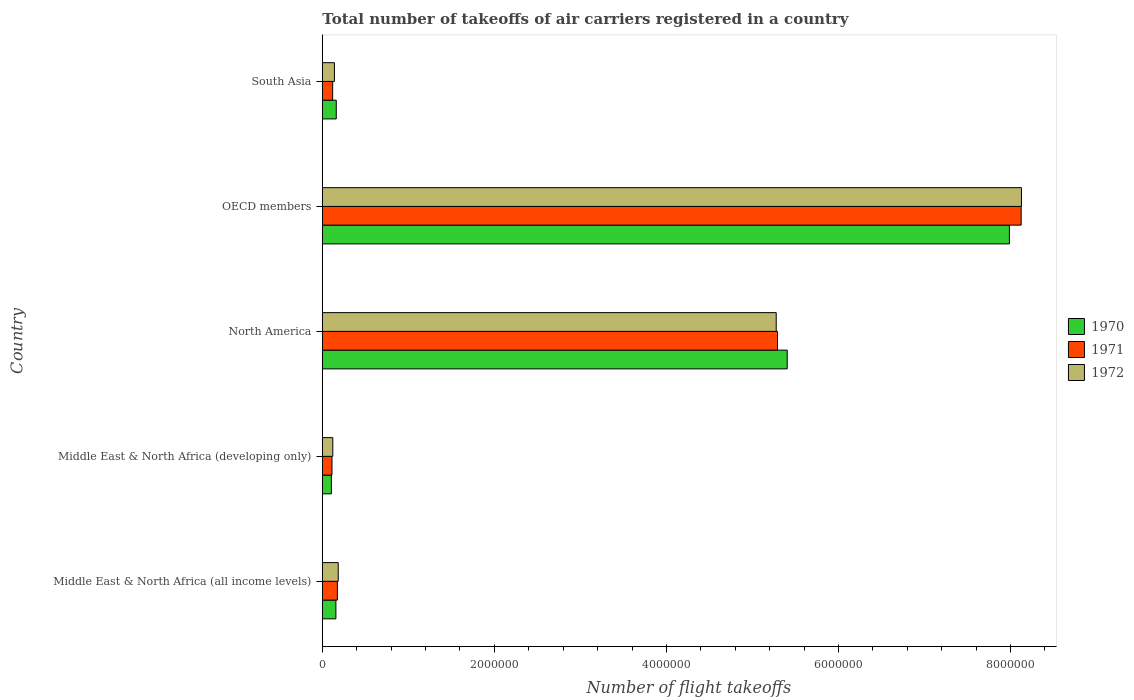How many different coloured bars are there?
Provide a short and direct response. 3. Are the number of bars per tick equal to the number of legend labels?
Your response must be concise. Yes. Are the number of bars on each tick of the Y-axis equal?
Ensure brevity in your answer.  Yes. How many bars are there on the 4th tick from the bottom?
Provide a short and direct response. 3. What is the label of the 1st group of bars from the top?
Provide a succinct answer. South Asia. In how many cases, is the number of bars for a given country not equal to the number of legend labels?
Make the answer very short. 0. What is the total number of flight takeoffs in 1972 in North America?
Provide a short and direct response. 5.28e+06. Across all countries, what is the maximum total number of flight takeoffs in 1972?
Provide a succinct answer. 8.13e+06. Across all countries, what is the minimum total number of flight takeoffs in 1971?
Offer a terse response. 1.12e+05. In which country was the total number of flight takeoffs in 1972 minimum?
Make the answer very short. Middle East & North Africa (developing only). What is the total total number of flight takeoffs in 1971 in the graph?
Offer a terse response. 1.38e+07. What is the difference between the total number of flight takeoffs in 1970 in Middle East & North Africa (all income levels) and that in South Asia?
Your response must be concise. -4300. What is the difference between the total number of flight takeoffs in 1971 in North America and the total number of flight takeoffs in 1970 in Middle East & North Africa (developing only)?
Your answer should be very brief. 5.19e+06. What is the average total number of flight takeoffs in 1972 per country?
Give a very brief answer. 2.77e+06. What is the ratio of the total number of flight takeoffs in 1972 in North America to that in OECD members?
Make the answer very short. 0.65. What is the difference between the highest and the second highest total number of flight takeoffs in 1970?
Offer a very short reply. 2.58e+06. What is the difference between the highest and the lowest total number of flight takeoffs in 1971?
Provide a short and direct response. 8.01e+06. Is the sum of the total number of flight takeoffs in 1971 in Middle East & North Africa (developing only) and North America greater than the maximum total number of flight takeoffs in 1970 across all countries?
Your answer should be very brief. No. What does the 3rd bar from the bottom in Middle East & North Africa (all income levels) represents?
Offer a very short reply. 1972. What is the difference between two consecutive major ticks on the X-axis?
Provide a short and direct response. 2.00e+06. Are the values on the major ticks of X-axis written in scientific E-notation?
Give a very brief answer. No. Does the graph contain any zero values?
Offer a very short reply. No. Does the graph contain grids?
Provide a short and direct response. No. What is the title of the graph?
Your response must be concise. Total number of takeoffs of air carriers registered in a country. Does "1995" appear as one of the legend labels in the graph?
Ensure brevity in your answer.  No. What is the label or title of the X-axis?
Your response must be concise. Number of flight takeoffs. What is the label or title of the Y-axis?
Your answer should be compact. Country. What is the Number of flight takeoffs in 1970 in Middle East & North Africa (all income levels)?
Keep it short and to the point. 1.58e+05. What is the Number of flight takeoffs in 1971 in Middle East & North Africa (all income levels)?
Your answer should be very brief. 1.75e+05. What is the Number of flight takeoffs in 1972 in Middle East & North Africa (all income levels)?
Give a very brief answer. 1.85e+05. What is the Number of flight takeoffs in 1970 in Middle East & North Africa (developing only)?
Keep it short and to the point. 1.05e+05. What is the Number of flight takeoffs of 1971 in Middle East & North Africa (developing only)?
Give a very brief answer. 1.12e+05. What is the Number of flight takeoffs in 1972 in Middle East & North Africa (developing only)?
Your response must be concise. 1.22e+05. What is the Number of flight takeoffs in 1970 in North America?
Provide a short and direct response. 5.40e+06. What is the Number of flight takeoffs of 1971 in North America?
Provide a short and direct response. 5.29e+06. What is the Number of flight takeoffs in 1972 in North America?
Keep it short and to the point. 5.28e+06. What is the Number of flight takeoffs in 1970 in OECD members?
Provide a short and direct response. 7.99e+06. What is the Number of flight takeoffs in 1971 in OECD members?
Provide a succinct answer. 8.12e+06. What is the Number of flight takeoffs in 1972 in OECD members?
Your response must be concise. 8.13e+06. What is the Number of flight takeoffs in 1970 in South Asia?
Ensure brevity in your answer.  1.62e+05. What is the Number of flight takeoffs of 1971 in South Asia?
Provide a short and direct response. 1.20e+05. What is the Number of flight takeoffs in 1972 in South Asia?
Ensure brevity in your answer.  1.41e+05. Across all countries, what is the maximum Number of flight takeoffs in 1970?
Your answer should be compact. 7.99e+06. Across all countries, what is the maximum Number of flight takeoffs of 1971?
Your response must be concise. 8.12e+06. Across all countries, what is the maximum Number of flight takeoffs of 1972?
Offer a very short reply. 8.13e+06. Across all countries, what is the minimum Number of flight takeoffs of 1970?
Provide a succinct answer. 1.05e+05. Across all countries, what is the minimum Number of flight takeoffs of 1971?
Offer a terse response. 1.12e+05. Across all countries, what is the minimum Number of flight takeoffs of 1972?
Offer a terse response. 1.22e+05. What is the total Number of flight takeoffs of 1970 in the graph?
Keep it short and to the point. 1.38e+07. What is the total Number of flight takeoffs in 1971 in the graph?
Offer a very short reply. 1.38e+07. What is the total Number of flight takeoffs of 1972 in the graph?
Keep it short and to the point. 1.39e+07. What is the difference between the Number of flight takeoffs of 1970 in Middle East & North Africa (all income levels) and that in Middle East & North Africa (developing only)?
Give a very brief answer. 5.23e+04. What is the difference between the Number of flight takeoffs of 1971 in Middle East & North Africa (all income levels) and that in Middle East & North Africa (developing only)?
Ensure brevity in your answer.  6.26e+04. What is the difference between the Number of flight takeoffs in 1972 in Middle East & North Africa (all income levels) and that in Middle East & North Africa (developing only)?
Provide a short and direct response. 6.32e+04. What is the difference between the Number of flight takeoffs in 1970 in Middle East & North Africa (all income levels) and that in North America?
Keep it short and to the point. -5.25e+06. What is the difference between the Number of flight takeoffs in 1971 in Middle East & North Africa (all income levels) and that in North America?
Your answer should be very brief. -5.12e+06. What is the difference between the Number of flight takeoffs in 1972 in Middle East & North Africa (all income levels) and that in North America?
Your answer should be compact. -5.09e+06. What is the difference between the Number of flight takeoffs in 1970 in Middle East & North Africa (all income levels) and that in OECD members?
Your response must be concise. -7.83e+06. What is the difference between the Number of flight takeoffs in 1971 in Middle East & North Africa (all income levels) and that in OECD members?
Your answer should be very brief. -7.95e+06. What is the difference between the Number of flight takeoffs in 1972 in Middle East & North Africa (all income levels) and that in OECD members?
Give a very brief answer. -7.94e+06. What is the difference between the Number of flight takeoffs of 1970 in Middle East & North Africa (all income levels) and that in South Asia?
Provide a short and direct response. -4300. What is the difference between the Number of flight takeoffs of 1971 in Middle East & North Africa (all income levels) and that in South Asia?
Make the answer very short. 5.48e+04. What is the difference between the Number of flight takeoffs in 1972 in Middle East & North Africa (all income levels) and that in South Asia?
Your answer should be very brief. 4.41e+04. What is the difference between the Number of flight takeoffs of 1970 in Middle East & North Africa (developing only) and that in North America?
Your answer should be compact. -5.30e+06. What is the difference between the Number of flight takeoffs in 1971 in Middle East & North Africa (developing only) and that in North America?
Your answer should be very brief. -5.18e+06. What is the difference between the Number of flight takeoffs of 1972 in Middle East & North Africa (developing only) and that in North America?
Your answer should be very brief. -5.15e+06. What is the difference between the Number of flight takeoffs in 1970 in Middle East & North Africa (developing only) and that in OECD members?
Your response must be concise. -7.88e+06. What is the difference between the Number of flight takeoffs of 1971 in Middle East & North Africa (developing only) and that in OECD members?
Offer a terse response. -8.01e+06. What is the difference between the Number of flight takeoffs in 1972 in Middle East & North Africa (developing only) and that in OECD members?
Provide a short and direct response. -8.01e+06. What is the difference between the Number of flight takeoffs of 1970 in Middle East & North Africa (developing only) and that in South Asia?
Provide a short and direct response. -5.66e+04. What is the difference between the Number of flight takeoffs in 1971 in Middle East & North Africa (developing only) and that in South Asia?
Offer a terse response. -7800. What is the difference between the Number of flight takeoffs in 1972 in Middle East & North Africa (developing only) and that in South Asia?
Offer a terse response. -1.91e+04. What is the difference between the Number of flight takeoffs in 1970 in North America and that in OECD members?
Give a very brief answer. -2.58e+06. What is the difference between the Number of flight takeoffs of 1971 in North America and that in OECD members?
Provide a short and direct response. -2.83e+06. What is the difference between the Number of flight takeoffs of 1972 in North America and that in OECD members?
Ensure brevity in your answer.  -2.85e+06. What is the difference between the Number of flight takeoffs of 1970 in North America and that in South Asia?
Offer a very short reply. 5.24e+06. What is the difference between the Number of flight takeoffs in 1971 in North America and that in South Asia?
Your answer should be compact. 5.17e+06. What is the difference between the Number of flight takeoffs in 1972 in North America and that in South Asia?
Your answer should be very brief. 5.14e+06. What is the difference between the Number of flight takeoffs in 1970 in OECD members and that in South Asia?
Offer a terse response. 7.83e+06. What is the difference between the Number of flight takeoffs of 1971 in OECD members and that in South Asia?
Give a very brief answer. 8.00e+06. What is the difference between the Number of flight takeoffs in 1972 in OECD members and that in South Asia?
Give a very brief answer. 7.99e+06. What is the difference between the Number of flight takeoffs in 1970 in Middle East & North Africa (all income levels) and the Number of flight takeoffs in 1971 in Middle East & North Africa (developing only)?
Keep it short and to the point. 4.54e+04. What is the difference between the Number of flight takeoffs in 1970 in Middle East & North Africa (all income levels) and the Number of flight takeoffs in 1972 in Middle East & North Africa (developing only)?
Ensure brevity in your answer.  3.60e+04. What is the difference between the Number of flight takeoffs in 1971 in Middle East & North Africa (all income levels) and the Number of flight takeoffs in 1972 in Middle East & North Africa (developing only)?
Give a very brief answer. 5.32e+04. What is the difference between the Number of flight takeoffs in 1970 in Middle East & North Africa (all income levels) and the Number of flight takeoffs in 1971 in North America?
Your answer should be compact. -5.13e+06. What is the difference between the Number of flight takeoffs in 1970 in Middle East & North Africa (all income levels) and the Number of flight takeoffs in 1972 in North America?
Make the answer very short. -5.12e+06. What is the difference between the Number of flight takeoffs of 1971 in Middle East & North Africa (all income levels) and the Number of flight takeoffs of 1972 in North America?
Your answer should be compact. -5.10e+06. What is the difference between the Number of flight takeoffs in 1970 in Middle East & North Africa (all income levels) and the Number of flight takeoffs in 1971 in OECD members?
Keep it short and to the point. -7.97e+06. What is the difference between the Number of flight takeoffs in 1970 in Middle East & North Africa (all income levels) and the Number of flight takeoffs in 1972 in OECD members?
Keep it short and to the point. -7.97e+06. What is the difference between the Number of flight takeoffs of 1971 in Middle East & North Africa (all income levels) and the Number of flight takeoffs of 1972 in OECD members?
Ensure brevity in your answer.  -7.95e+06. What is the difference between the Number of flight takeoffs in 1970 in Middle East & North Africa (all income levels) and the Number of flight takeoffs in 1971 in South Asia?
Keep it short and to the point. 3.76e+04. What is the difference between the Number of flight takeoffs in 1970 in Middle East & North Africa (all income levels) and the Number of flight takeoffs in 1972 in South Asia?
Provide a succinct answer. 1.69e+04. What is the difference between the Number of flight takeoffs of 1971 in Middle East & North Africa (all income levels) and the Number of flight takeoffs of 1972 in South Asia?
Ensure brevity in your answer.  3.41e+04. What is the difference between the Number of flight takeoffs in 1970 in Middle East & North Africa (developing only) and the Number of flight takeoffs in 1971 in North America?
Offer a very short reply. -5.19e+06. What is the difference between the Number of flight takeoffs of 1970 in Middle East & North Africa (developing only) and the Number of flight takeoffs of 1972 in North America?
Your response must be concise. -5.17e+06. What is the difference between the Number of flight takeoffs of 1971 in Middle East & North Africa (developing only) and the Number of flight takeoffs of 1972 in North America?
Offer a terse response. -5.16e+06. What is the difference between the Number of flight takeoffs of 1970 in Middle East & North Africa (developing only) and the Number of flight takeoffs of 1971 in OECD members?
Make the answer very short. -8.02e+06. What is the difference between the Number of flight takeoffs of 1970 in Middle East & North Africa (developing only) and the Number of flight takeoffs of 1972 in OECD members?
Your answer should be very brief. -8.02e+06. What is the difference between the Number of flight takeoffs in 1971 in Middle East & North Africa (developing only) and the Number of flight takeoffs in 1972 in OECD members?
Give a very brief answer. -8.02e+06. What is the difference between the Number of flight takeoffs of 1970 in Middle East & North Africa (developing only) and the Number of flight takeoffs of 1971 in South Asia?
Ensure brevity in your answer.  -1.47e+04. What is the difference between the Number of flight takeoffs of 1970 in Middle East & North Africa (developing only) and the Number of flight takeoffs of 1972 in South Asia?
Offer a terse response. -3.54e+04. What is the difference between the Number of flight takeoffs of 1971 in Middle East & North Africa (developing only) and the Number of flight takeoffs of 1972 in South Asia?
Your answer should be compact. -2.85e+04. What is the difference between the Number of flight takeoffs of 1970 in North America and the Number of flight takeoffs of 1971 in OECD members?
Ensure brevity in your answer.  -2.72e+06. What is the difference between the Number of flight takeoffs in 1970 in North America and the Number of flight takeoffs in 1972 in OECD members?
Provide a succinct answer. -2.72e+06. What is the difference between the Number of flight takeoffs in 1971 in North America and the Number of flight takeoffs in 1972 in OECD members?
Your answer should be very brief. -2.84e+06. What is the difference between the Number of flight takeoffs of 1970 in North America and the Number of flight takeoffs of 1971 in South Asia?
Your answer should be compact. 5.28e+06. What is the difference between the Number of flight takeoffs in 1970 in North America and the Number of flight takeoffs in 1972 in South Asia?
Make the answer very short. 5.26e+06. What is the difference between the Number of flight takeoffs in 1971 in North America and the Number of flight takeoffs in 1972 in South Asia?
Offer a terse response. 5.15e+06. What is the difference between the Number of flight takeoffs of 1970 in OECD members and the Number of flight takeoffs of 1971 in South Asia?
Your response must be concise. 7.87e+06. What is the difference between the Number of flight takeoffs in 1970 in OECD members and the Number of flight takeoffs in 1972 in South Asia?
Provide a short and direct response. 7.85e+06. What is the difference between the Number of flight takeoffs of 1971 in OECD members and the Number of flight takeoffs of 1972 in South Asia?
Your answer should be compact. 7.98e+06. What is the average Number of flight takeoffs in 1970 per country?
Provide a short and direct response. 2.76e+06. What is the average Number of flight takeoffs in 1971 per country?
Provide a short and direct response. 2.76e+06. What is the average Number of flight takeoffs in 1972 per country?
Give a very brief answer. 2.77e+06. What is the difference between the Number of flight takeoffs in 1970 and Number of flight takeoffs in 1971 in Middle East & North Africa (all income levels)?
Provide a succinct answer. -1.72e+04. What is the difference between the Number of flight takeoffs in 1970 and Number of flight takeoffs in 1972 in Middle East & North Africa (all income levels)?
Provide a succinct answer. -2.72e+04. What is the difference between the Number of flight takeoffs of 1970 and Number of flight takeoffs of 1971 in Middle East & North Africa (developing only)?
Give a very brief answer. -6900. What is the difference between the Number of flight takeoffs in 1970 and Number of flight takeoffs in 1972 in Middle East & North Africa (developing only)?
Provide a succinct answer. -1.63e+04. What is the difference between the Number of flight takeoffs of 1971 and Number of flight takeoffs of 1972 in Middle East & North Africa (developing only)?
Offer a very short reply. -9400. What is the difference between the Number of flight takeoffs of 1970 and Number of flight takeoffs of 1971 in North America?
Ensure brevity in your answer.  1.13e+05. What is the difference between the Number of flight takeoffs in 1970 and Number of flight takeoffs in 1972 in North America?
Give a very brief answer. 1.28e+05. What is the difference between the Number of flight takeoffs in 1971 and Number of flight takeoffs in 1972 in North America?
Give a very brief answer. 1.51e+04. What is the difference between the Number of flight takeoffs in 1970 and Number of flight takeoffs in 1971 in OECD members?
Ensure brevity in your answer.  -1.37e+05. What is the difference between the Number of flight takeoffs in 1970 and Number of flight takeoffs in 1972 in OECD members?
Offer a terse response. -1.40e+05. What is the difference between the Number of flight takeoffs of 1971 and Number of flight takeoffs of 1972 in OECD members?
Provide a succinct answer. -3600. What is the difference between the Number of flight takeoffs in 1970 and Number of flight takeoffs in 1971 in South Asia?
Offer a terse response. 4.19e+04. What is the difference between the Number of flight takeoffs of 1970 and Number of flight takeoffs of 1972 in South Asia?
Ensure brevity in your answer.  2.12e+04. What is the difference between the Number of flight takeoffs of 1971 and Number of flight takeoffs of 1972 in South Asia?
Offer a terse response. -2.07e+04. What is the ratio of the Number of flight takeoffs in 1970 in Middle East & North Africa (all income levels) to that in Middle East & North Africa (developing only)?
Your response must be concise. 1.5. What is the ratio of the Number of flight takeoffs in 1971 in Middle East & North Africa (all income levels) to that in Middle East & North Africa (developing only)?
Provide a succinct answer. 1.56. What is the ratio of the Number of flight takeoffs of 1972 in Middle East & North Africa (all income levels) to that in Middle East & North Africa (developing only)?
Give a very brief answer. 1.52. What is the ratio of the Number of flight takeoffs of 1970 in Middle East & North Africa (all income levels) to that in North America?
Your answer should be very brief. 0.03. What is the ratio of the Number of flight takeoffs in 1971 in Middle East & North Africa (all income levels) to that in North America?
Offer a terse response. 0.03. What is the ratio of the Number of flight takeoffs in 1972 in Middle East & North Africa (all income levels) to that in North America?
Your response must be concise. 0.04. What is the ratio of the Number of flight takeoffs of 1970 in Middle East & North Africa (all income levels) to that in OECD members?
Give a very brief answer. 0.02. What is the ratio of the Number of flight takeoffs of 1971 in Middle East & North Africa (all income levels) to that in OECD members?
Your response must be concise. 0.02. What is the ratio of the Number of flight takeoffs in 1972 in Middle East & North Africa (all income levels) to that in OECD members?
Give a very brief answer. 0.02. What is the ratio of the Number of flight takeoffs in 1970 in Middle East & North Africa (all income levels) to that in South Asia?
Ensure brevity in your answer.  0.97. What is the ratio of the Number of flight takeoffs in 1971 in Middle East & North Africa (all income levels) to that in South Asia?
Your answer should be compact. 1.46. What is the ratio of the Number of flight takeoffs in 1972 in Middle East & North Africa (all income levels) to that in South Asia?
Your response must be concise. 1.31. What is the ratio of the Number of flight takeoffs in 1970 in Middle East & North Africa (developing only) to that in North America?
Offer a terse response. 0.02. What is the ratio of the Number of flight takeoffs in 1971 in Middle East & North Africa (developing only) to that in North America?
Your answer should be very brief. 0.02. What is the ratio of the Number of flight takeoffs of 1972 in Middle East & North Africa (developing only) to that in North America?
Offer a very short reply. 0.02. What is the ratio of the Number of flight takeoffs of 1970 in Middle East & North Africa (developing only) to that in OECD members?
Offer a very short reply. 0.01. What is the ratio of the Number of flight takeoffs of 1971 in Middle East & North Africa (developing only) to that in OECD members?
Offer a terse response. 0.01. What is the ratio of the Number of flight takeoffs in 1972 in Middle East & North Africa (developing only) to that in OECD members?
Provide a succinct answer. 0.01. What is the ratio of the Number of flight takeoffs in 1970 in Middle East & North Africa (developing only) to that in South Asia?
Provide a succinct answer. 0.65. What is the ratio of the Number of flight takeoffs of 1971 in Middle East & North Africa (developing only) to that in South Asia?
Make the answer very short. 0.94. What is the ratio of the Number of flight takeoffs of 1972 in Middle East & North Africa (developing only) to that in South Asia?
Your answer should be very brief. 0.86. What is the ratio of the Number of flight takeoffs in 1970 in North America to that in OECD members?
Give a very brief answer. 0.68. What is the ratio of the Number of flight takeoffs in 1971 in North America to that in OECD members?
Your response must be concise. 0.65. What is the ratio of the Number of flight takeoffs of 1972 in North America to that in OECD members?
Your answer should be very brief. 0.65. What is the ratio of the Number of flight takeoffs in 1970 in North America to that in South Asia?
Keep it short and to the point. 33.36. What is the ratio of the Number of flight takeoffs of 1971 in North America to that in South Asia?
Offer a very short reply. 44.06. What is the ratio of the Number of flight takeoffs of 1972 in North America to that in South Asia?
Offer a very short reply. 37.48. What is the ratio of the Number of flight takeoffs in 1970 in OECD members to that in South Asia?
Provide a short and direct response. 49.3. What is the ratio of the Number of flight takeoffs in 1971 in OECD members to that in South Asia?
Keep it short and to the point. 67.64. What is the ratio of the Number of flight takeoffs in 1972 in OECD members to that in South Asia?
Offer a very short reply. 57.73. What is the difference between the highest and the second highest Number of flight takeoffs of 1970?
Give a very brief answer. 2.58e+06. What is the difference between the highest and the second highest Number of flight takeoffs of 1971?
Make the answer very short. 2.83e+06. What is the difference between the highest and the second highest Number of flight takeoffs of 1972?
Your answer should be compact. 2.85e+06. What is the difference between the highest and the lowest Number of flight takeoffs in 1970?
Your response must be concise. 7.88e+06. What is the difference between the highest and the lowest Number of flight takeoffs of 1971?
Make the answer very short. 8.01e+06. What is the difference between the highest and the lowest Number of flight takeoffs in 1972?
Offer a very short reply. 8.01e+06. 